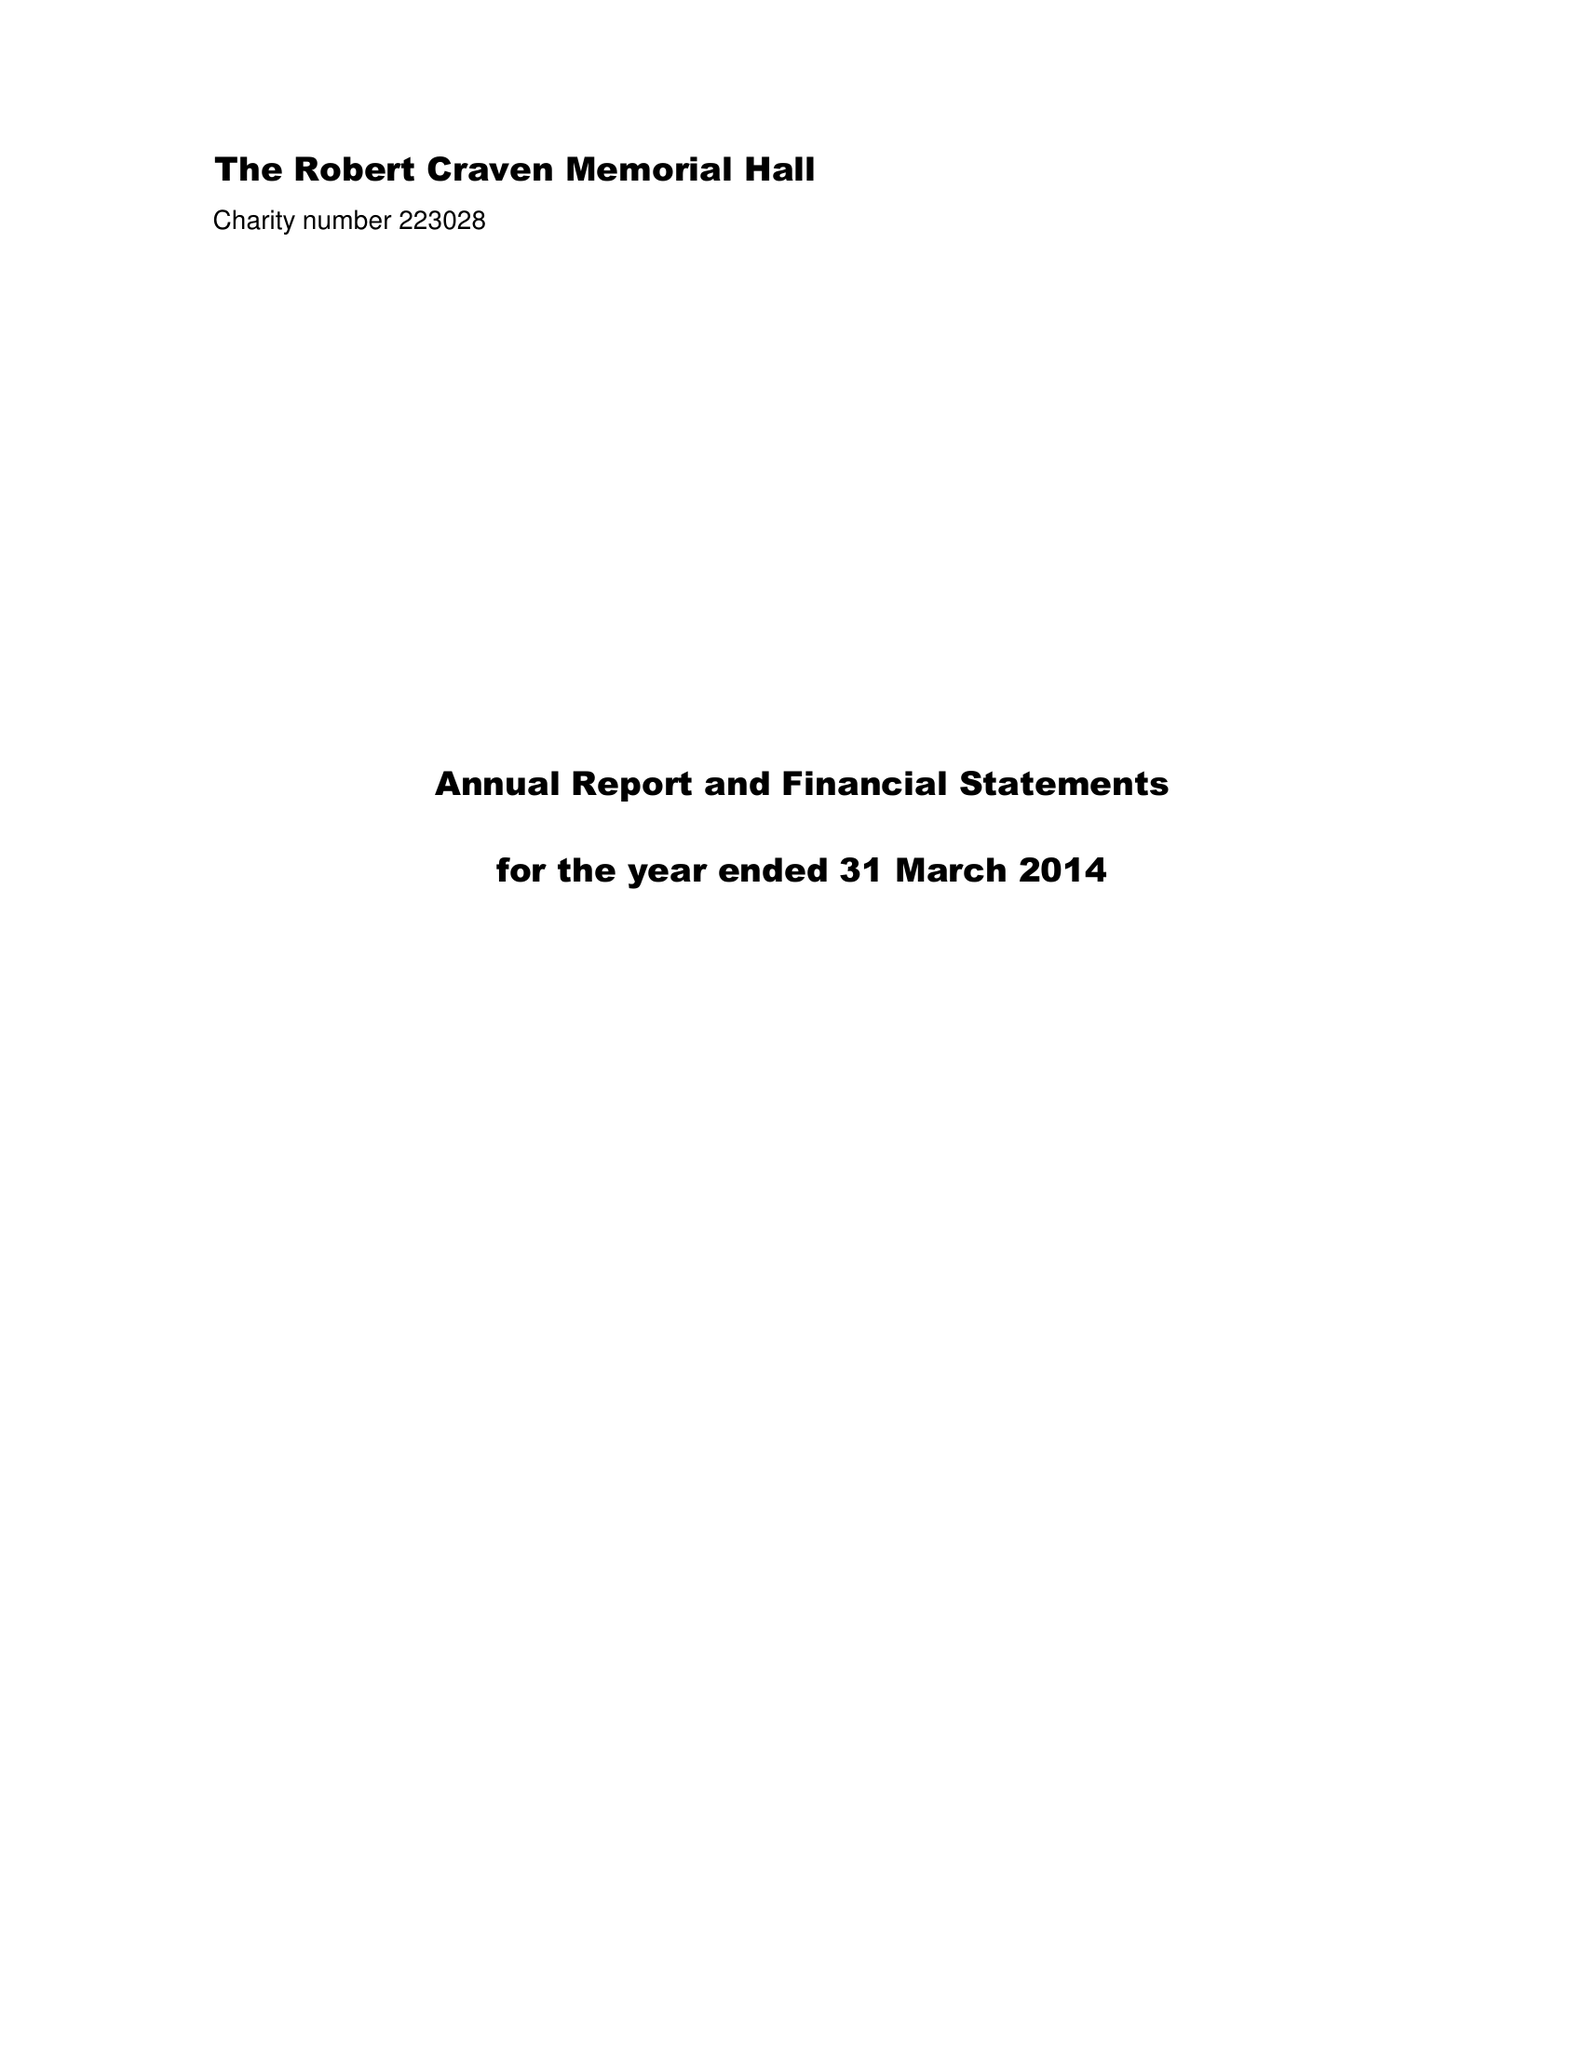What is the value for the address__post_town?
Answer the question using a single word or phrase. LEEDS 